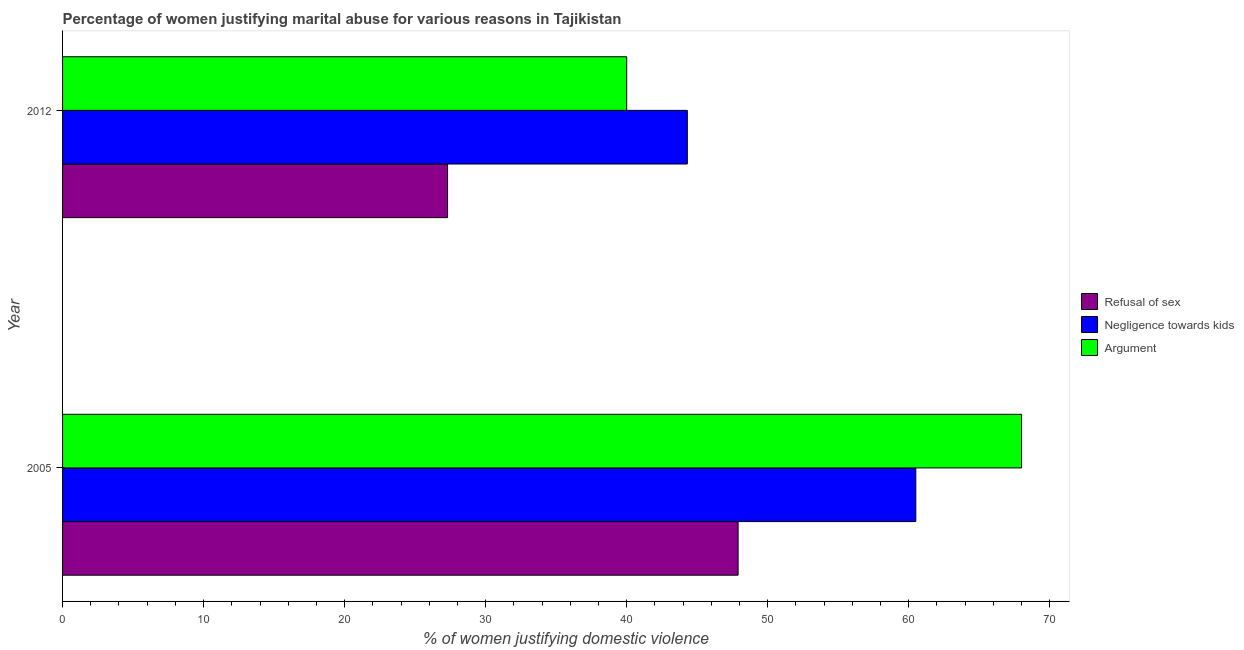How many different coloured bars are there?
Your answer should be compact. 3. Are the number of bars per tick equal to the number of legend labels?
Provide a short and direct response. Yes. How many bars are there on the 2nd tick from the bottom?
Offer a very short reply. 3. What is the label of the 1st group of bars from the top?
Your answer should be compact. 2012. In how many cases, is the number of bars for a given year not equal to the number of legend labels?
Ensure brevity in your answer.  0. What is the percentage of women justifying domestic violence due to arguments in 2005?
Make the answer very short. 68. Across all years, what is the maximum percentage of women justifying domestic violence due to arguments?
Offer a terse response. 68. Across all years, what is the minimum percentage of women justifying domestic violence due to negligence towards kids?
Your answer should be very brief. 44.3. What is the total percentage of women justifying domestic violence due to refusal of sex in the graph?
Provide a succinct answer. 75.2. What is the difference between the percentage of women justifying domestic violence due to arguments in 2005 and that in 2012?
Your answer should be compact. 28. What is the difference between the percentage of women justifying domestic violence due to negligence towards kids in 2005 and the percentage of women justifying domestic violence due to refusal of sex in 2012?
Offer a terse response. 33.2. In the year 2012, what is the difference between the percentage of women justifying domestic violence due to arguments and percentage of women justifying domestic violence due to refusal of sex?
Ensure brevity in your answer.  12.7. What is the ratio of the percentage of women justifying domestic violence due to arguments in 2005 to that in 2012?
Provide a short and direct response. 1.7. Is the percentage of women justifying domestic violence due to arguments in 2005 less than that in 2012?
Your response must be concise. No. Is the difference between the percentage of women justifying domestic violence due to arguments in 2005 and 2012 greater than the difference between the percentage of women justifying domestic violence due to negligence towards kids in 2005 and 2012?
Ensure brevity in your answer.  Yes. What does the 2nd bar from the top in 2005 represents?
Your answer should be very brief. Negligence towards kids. What does the 2nd bar from the bottom in 2005 represents?
Provide a short and direct response. Negligence towards kids. How many years are there in the graph?
Your answer should be compact. 2. What is the difference between two consecutive major ticks on the X-axis?
Give a very brief answer. 10. Does the graph contain grids?
Your answer should be compact. No. How are the legend labels stacked?
Offer a very short reply. Vertical. What is the title of the graph?
Offer a terse response. Percentage of women justifying marital abuse for various reasons in Tajikistan. What is the label or title of the X-axis?
Offer a terse response. % of women justifying domestic violence. What is the label or title of the Y-axis?
Provide a short and direct response. Year. What is the % of women justifying domestic violence in Refusal of sex in 2005?
Make the answer very short. 47.9. What is the % of women justifying domestic violence of Negligence towards kids in 2005?
Make the answer very short. 60.5. What is the % of women justifying domestic violence in Argument in 2005?
Keep it short and to the point. 68. What is the % of women justifying domestic violence of Refusal of sex in 2012?
Make the answer very short. 27.3. What is the % of women justifying domestic violence in Negligence towards kids in 2012?
Provide a short and direct response. 44.3. What is the % of women justifying domestic violence in Argument in 2012?
Offer a very short reply. 40. Across all years, what is the maximum % of women justifying domestic violence of Refusal of sex?
Keep it short and to the point. 47.9. Across all years, what is the maximum % of women justifying domestic violence of Negligence towards kids?
Provide a succinct answer. 60.5. Across all years, what is the minimum % of women justifying domestic violence of Refusal of sex?
Ensure brevity in your answer.  27.3. Across all years, what is the minimum % of women justifying domestic violence of Negligence towards kids?
Your response must be concise. 44.3. Across all years, what is the minimum % of women justifying domestic violence in Argument?
Offer a very short reply. 40. What is the total % of women justifying domestic violence of Refusal of sex in the graph?
Give a very brief answer. 75.2. What is the total % of women justifying domestic violence of Negligence towards kids in the graph?
Ensure brevity in your answer.  104.8. What is the total % of women justifying domestic violence of Argument in the graph?
Make the answer very short. 108. What is the difference between the % of women justifying domestic violence in Refusal of sex in 2005 and that in 2012?
Offer a very short reply. 20.6. What is the difference between the % of women justifying domestic violence of Negligence towards kids in 2005 and that in 2012?
Give a very brief answer. 16.2. What is the average % of women justifying domestic violence of Refusal of sex per year?
Ensure brevity in your answer.  37.6. What is the average % of women justifying domestic violence of Negligence towards kids per year?
Provide a succinct answer. 52.4. What is the average % of women justifying domestic violence in Argument per year?
Your answer should be very brief. 54. In the year 2005, what is the difference between the % of women justifying domestic violence of Refusal of sex and % of women justifying domestic violence of Argument?
Give a very brief answer. -20.1. In the year 2005, what is the difference between the % of women justifying domestic violence in Negligence towards kids and % of women justifying domestic violence in Argument?
Provide a short and direct response. -7.5. What is the ratio of the % of women justifying domestic violence of Refusal of sex in 2005 to that in 2012?
Your response must be concise. 1.75. What is the ratio of the % of women justifying domestic violence of Negligence towards kids in 2005 to that in 2012?
Your response must be concise. 1.37. What is the difference between the highest and the second highest % of women justifying domestic violence of Refusal of sex?
Offer a terse response. 20.6. What is the difference between the highest and the second highest % of women justifying domestic violence in Argument?
Your answer should be compact. 28. What is the difference between the highest and the lowest % of women justifying domestic violence in Refusal of sex?
Your answer should be very brief. 20.6. What is the difference between the highest and the lowest % of women justifying domestic violence of Negligence towards kids?
Your response must be concise. 16.2. 